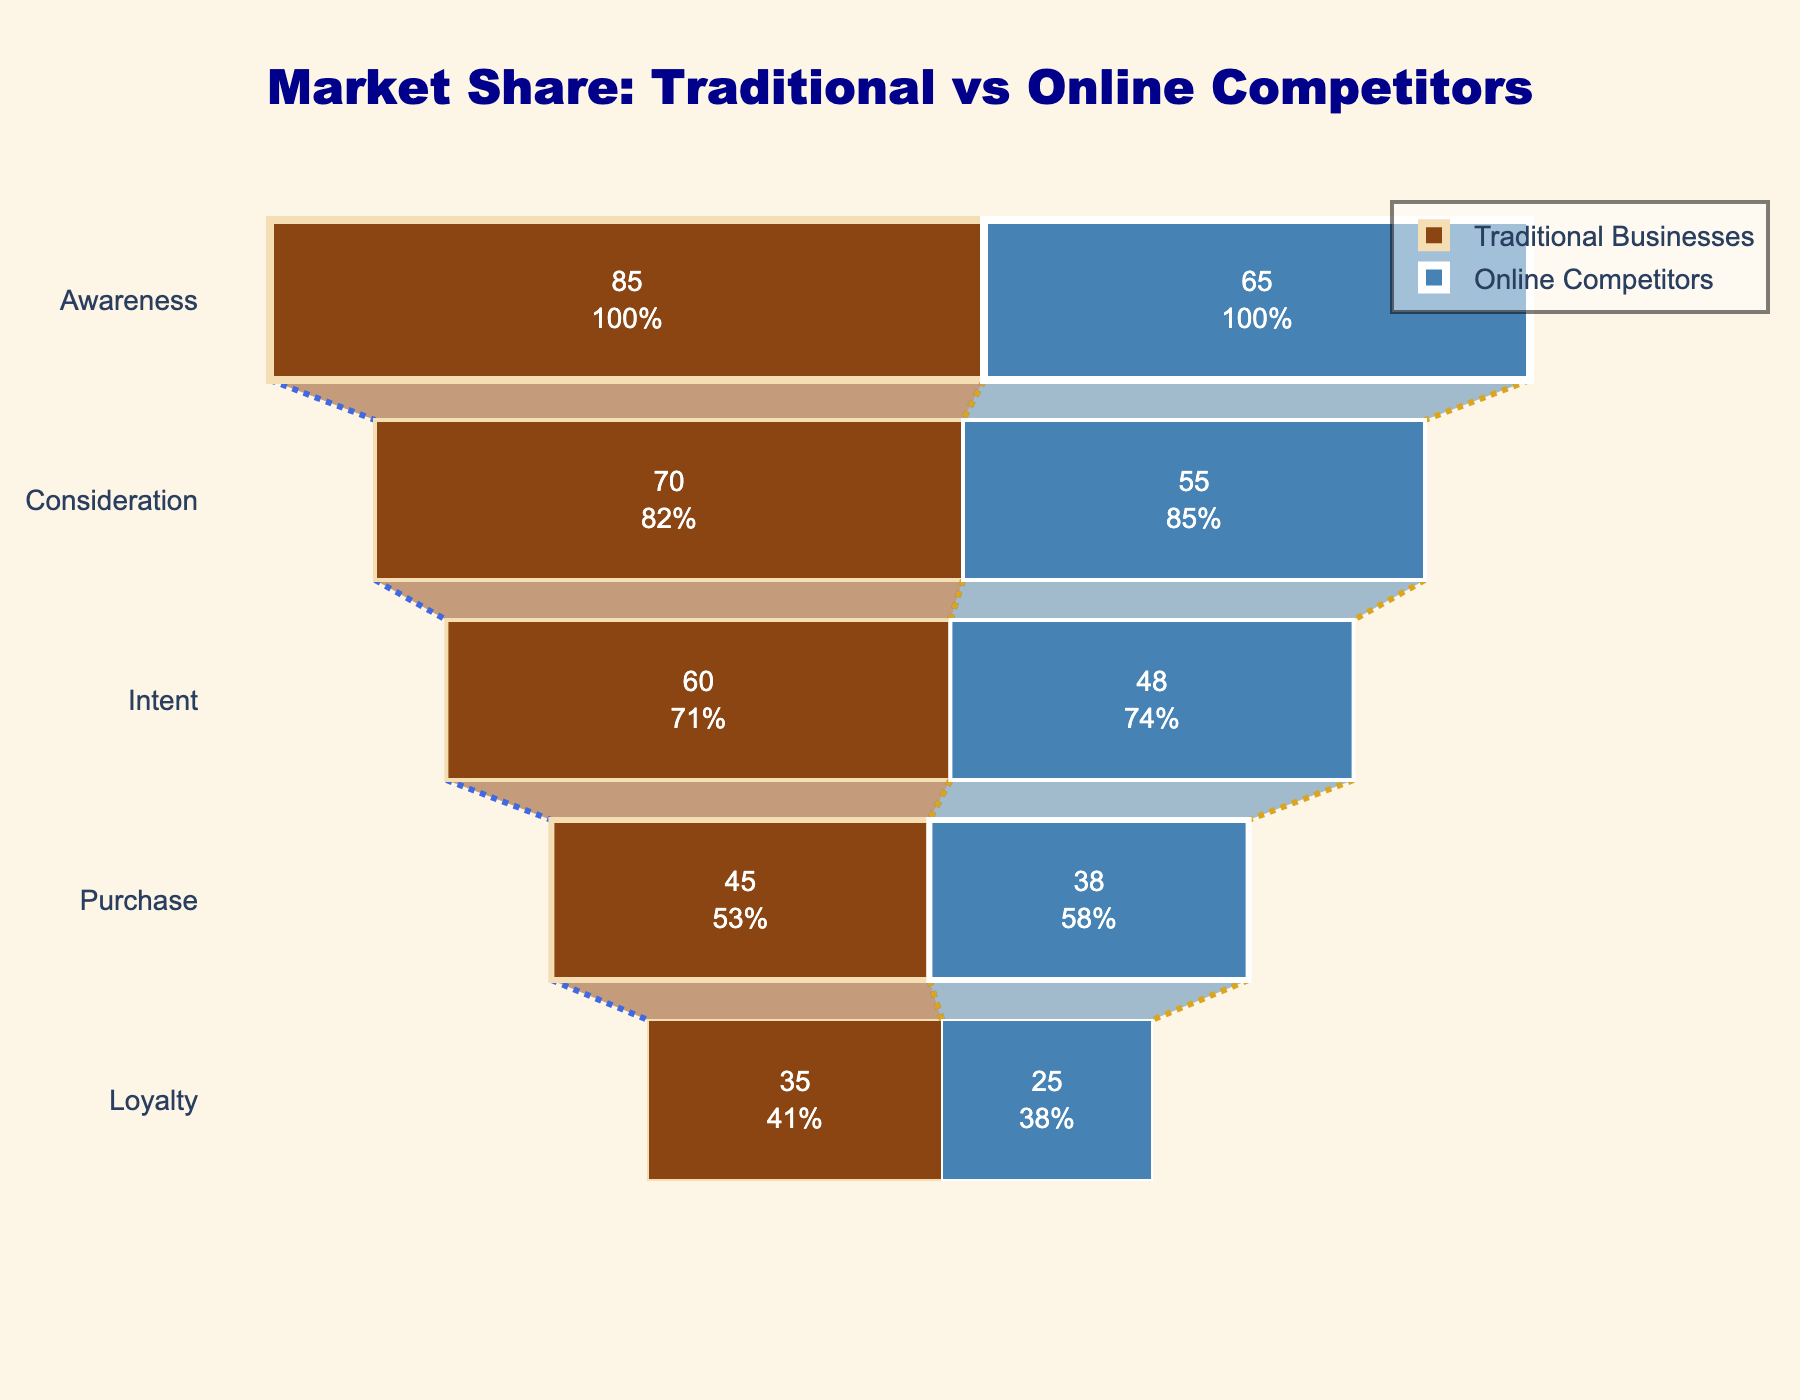What is the title of the funnel chart? The title is displayed at the top of the funnel chart. It reads "Market Share: Traditional vs Online Competitors".
Answer: Market Share: Traditional vs Online Competitors What are the two categories compared in the funnel chart? The two categories are labeled at the top of their respective funnel sections: "Traditional Businesses" and "Online Competitors".
Answer: Traditional Businesses and Online Competitors Which stage shows the highest percentage for Traditional Businesses? Looking at the funnel segments for Traditional Businesses, the Awareness stage has the highest percentage at 85%.
Answer: Awareness At which stage do Online Competitors have their lowest percentage? Observe the sections of the funnel for Online Competitors. The Loyalty stage has the lowest percentage at 25%.
Answer: Loyalty How does the percentage of Purchase stage compare between Traditional Businesses and Online Competitors? By examining the Purchase stage across both funnels, Traditional Businesses have 45% and Online Competitors have 38%. \
Answer: 45% vs 38% What is the difference in percentages between the Awareness and Loyalty stages for Traditional Businesses? Subtract the Loyalty stage percentage from the Awareness stage percentage for Traditional Businesses: 85% - 35% = 50%.
Answer: 50% How many stages see a higher percentage for Traditional Businesses compared to Online Competitors? Compare the percentages at each stage: Awareness (85% vs 65%), Consideration (70% vs 55%), Intent (60% vs 48%), Purchase (45% vs 38%), Loyalty (35% vs 25%). All stages have a higher percentage for Traditional Businesses.
Answer: 5 Which category shows less drop-off from Awareness to Consideration stage? Calculate the drop-off: Traditional Businesses drop from 85% to 70% (15% drop), Online Competitors drop from 65% to 55% (10% drop).
Answer: Online Competitors By how much is the Loyalty stage higher in percentage for Traditional Businesses compared to Online Competitors? Subtract the Loyalty stage percentage of Online Competitors from that of Traditional Businesses: 35% - 25% = 10%.
Answer: 10% What is the combined percentage of Traditional Businesses at the Intent and Purchase stages? Add the percentages for Traditional Businesses at the Intent and Purchase stages: 60% + 45% = 105%.
Answer: 105% 